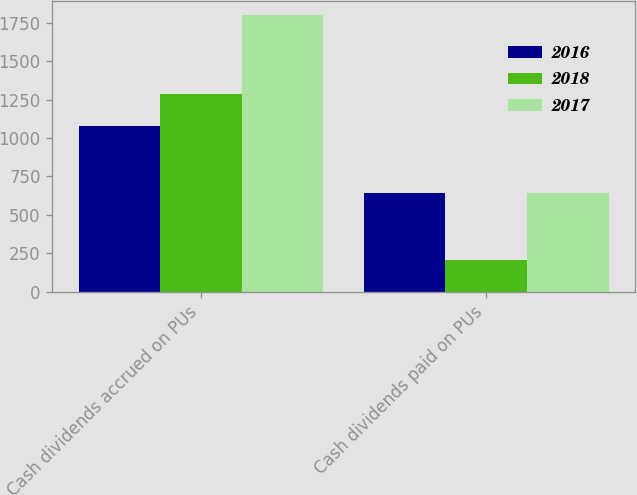<chart> <loc_0><loc_0><loc_500><loc_500><stacked_bar_chart><ecel><fcel>Cash dividends accrued on PUs<fcel>Cash dividends paid on PUs<nl><fcel>2016<fcel>1078<fcel>645<nl><fcel>2018<fcel>1290<fcel>205<nl><fcel>2017<fcel>1804<fcel>644<nl></chart> 